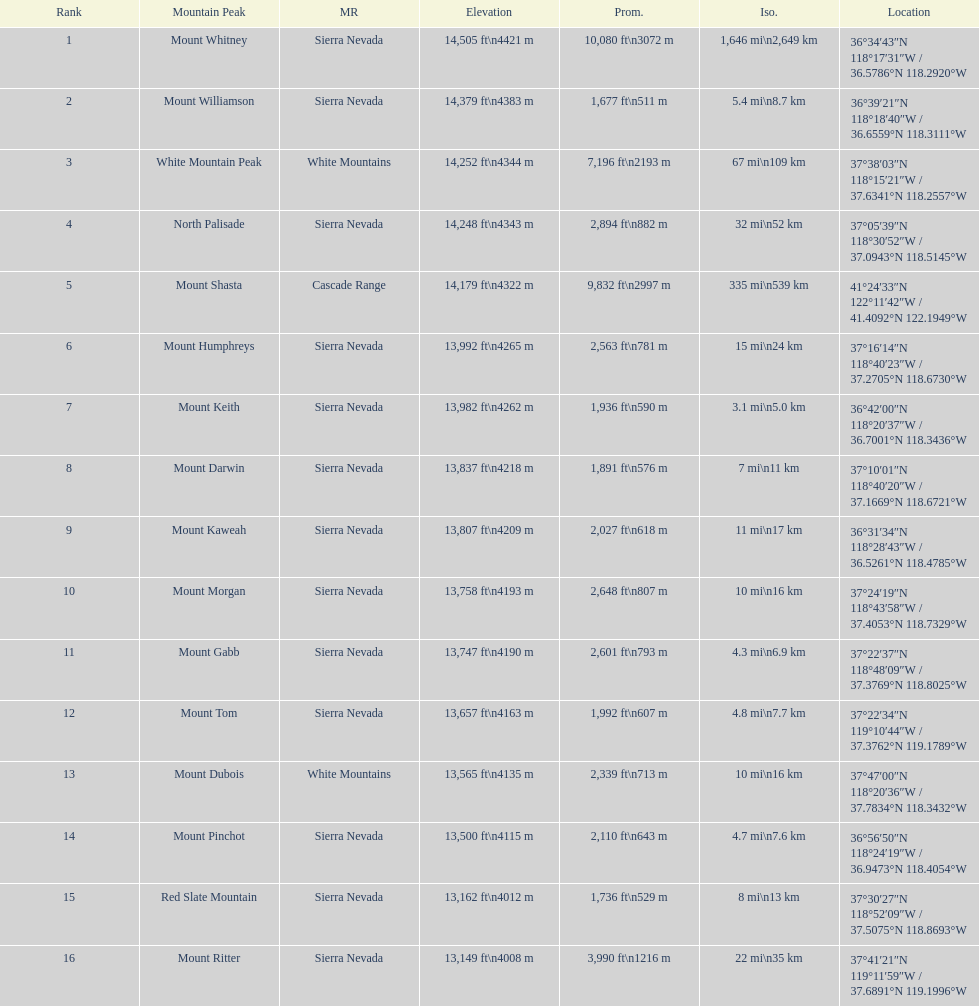Can you parse all the data within this table? {'header': ['Rank', 'Mountain Peak', 'MR', 'Elevation', 'Prom.', 'Iso.', 'Location'], 'rows': [['1', 'Mount Whitney', 'Sierra Nevada', '14,505\xa0ft\\n4421\xa0m', '10,080\xa0ft\\n3072\xa0m', '1,646\xa0mi\\n2,649\xa0km', '36°34′43″N 118°17′31″W\ufeff / \ufeff36.5786°N 118.2920°W'], ['2', 'Mount Williamson', 'Sierra Nevada', '14,379\xa0ft\\n4383\xa0m', '1,677\xa0ft\\n511\xa0m', '5.4\xa0mi\\n8.7\xa0km', '36°39′21″N 118°18′40″W\ufeff / \ufeff36.6559°N 118.3111°W'], ['3', 'White Mountain Peak', 'White Mountains', '14,252\xa0ft\\n4344\xa0m', '7,196\xa0ft\\n2193\xa0m', '67\xa0mi\\n109\xa0km', '37°38′03″N 118°15′21″W\ufeff / \ufeff37.6341°N 118.2557°W'], ['4', 'North Palisade', 'Sierra Nevada', '14,248\xa0ft\\n4343\xa0m', '2,894\xa0ft\\n882\xa0m', '32\xa0mi\\n52\xa0km', '37°05′39″N 118°30′52″W\ufeff / \ufeff37.0943°N 118.5145°W'], ['5', 'Mount Shasta', 'Cascade Range', '14,179\xa0ft\\n4322\xa0m', '9,832\xa0ft\\n2997\xa0m', '335\xa0mi\\n539\xa0km', '41°24′33″N 122°11′42″W\ufeff / \ufeff41.4092°N 122.1949°W'], ['6', 'Mount Humphreys', 'Sierra Nevada', '13,992\xa0ft\\n4265\xa0m', '2,563\xa0ft\\n781\xa0m', '15\xa0mi\\n24\xa0km', '37°16′14″N 118°40′23″W\ufeff / \ufeff37.2705°N 118.6730°W'], ['7', 'Mount Keith', 'Sierra Nevada', '13,982\xa0ft\\n4262\xa0m', '1,936\xa0ft\\n590\xa0m', '3.1\xa0mi\\n5.0\xa0km', '36°42′00″N 118°20′37″W\ufeff / \ufeff36.7001°N 118.3436°W'], ['8', 'Mount Darwin', 'Sierra Nevada', '13,837\xa0ft\\n4218\xa0m', '1,891\xa0ft\\n576\xa0m', '7\xa0mi\\n11\xa0km', '37°10′01″N 118°40′20″W\ufeff / \ufeff37.1669°N 118.6721°W'], ['9', 'Mount Kaweah', 'Sierra Nevada', '13,807\xa0ft\\n4209\xa0m', '2,027\xa0ft\\n618\xa0m', '11\xa0mi\\n17\xa0km', '36°31′34″N 118°28′43″W\ufeff / \ufeff36.5261°N 118.4785°W'], ['10', 'Mount Morgan', 'Sierra Nevada', '13,758\xa0ft\\n4193\xa0m', '2,648\xa0ft\\n807\xa0m', '10\xa0mi\\n16\xa0km', '37°24′19″N 118°43′58″W\ufeff / \ufeff37.4053°N 118.7329°W'], ['11', 'Mount Gabb', 'Sierra Nevada', '13,747\xa0ft\\n4190\xa0m', '2,601\xa0ft\\n793\xa0m', '4.3\xa0mi\\n6.9\xa0km', '37°22′37″N 118°48′09″W\ufeff / \ufeff37.3769°N 118.8025°W'], ['12', 'Mount Tom', 'Sierra Nevada', '13,657\xa0ft\\n4163\xa0m', '1,992\xa0ft\\n607\xa0m', '4.8\xa0mi\\n7.7\xa0km', '37°22′34″N 119°10′44″W\ufeff / \ufeff37.3762°N 119.1789°W'], ['13', 'Mount Dubois', 'White Mountains', '13,565\xa0ft\\n4135\xa0m', '2,339\xa0ft\\n713\xa0m', '10\xa0mi\\n16\xa0km', '37°47′00″N 118°20′36″W\ufeff / \ufeff37.7834°N 118.3432°W'], ['14', 'Mount Pinchot', 'Sierra Nevada', '13,500\xa0ft\\n4115\xa0m', '2,110\xa0ft\\n643\xa0m', '4.7\xa0mi\\n7.6\xa0km', '36°56′50″N 118°24′19″W\ufeff / \ufeff36.9473°N 118.4054°W'], ['15', 'Red Slate Mountain', 'Sierra Nevada', '13,162\xa0ft\\n4012\xa0m', '1,736\xa0ft\\n529\xa0m', '8\xa0mi\\n13\xa0km', '37°30′27″N 118°52′09″W\ufeff / \ufeff37.5075°N 118.8693°W'], ['16', 'Mount Ritter', 'Sierra Nevada', '13,149\xa0ft\\n4008\xa0m', '3,990\xa0ft\\n1216\xa0m', '22\xa0mi\\n35\xa0km', '37°41′21″N 119°11′59″W\ufeff / \ufeff37.6891°N 119.1996°W']]} Which mountain peak has the least isolation? Mount Keith. 